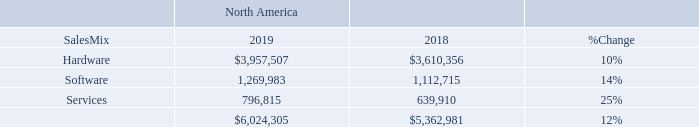Our net sales by offering category for North America for 2019 and 2018, were as follows (dollars
in thousands):
Net sales in North America increased 12%, or $661.3 million, in 2019 compared to 2018. This increase reflects the addition of PCM, which reported $716.1 million in net sales in 2019, partially offset by a decline in net sales of the core business of $51.3 million. Net sales of hardware, software and services increased 10%, 14% and 25%, respectively, year over year.
How much did the Net sales in North America increased in 2019 compared to 2018? $661.3 million. What is the net sales of software in 2019 and 2018 respectively?
Answer scale should be: thousand. 1,269,983, 1,112,715. What is the net sales of hardware in 2019 and 2018 respectively?
Answer scale should be: thousand. $3,957,507, $3,610,356. What is the change in Sales Mix of Hardware betweeen 2018 and 2019?
Answer scale should be: thousand. 3,957,507-3,610,356
Answer: 347151. What is the change in Sales Mix of Software between 2018 and 2019?
Answer scale should be: thousand. 1,269,983-1,112,715
Answer: 157268. What is the average Sales Mix of Hardware for 2018 and 2019?
Answer scale should be: thousand. (3,957,507+3,610,356) / 2
Answer: 3783931.5. 